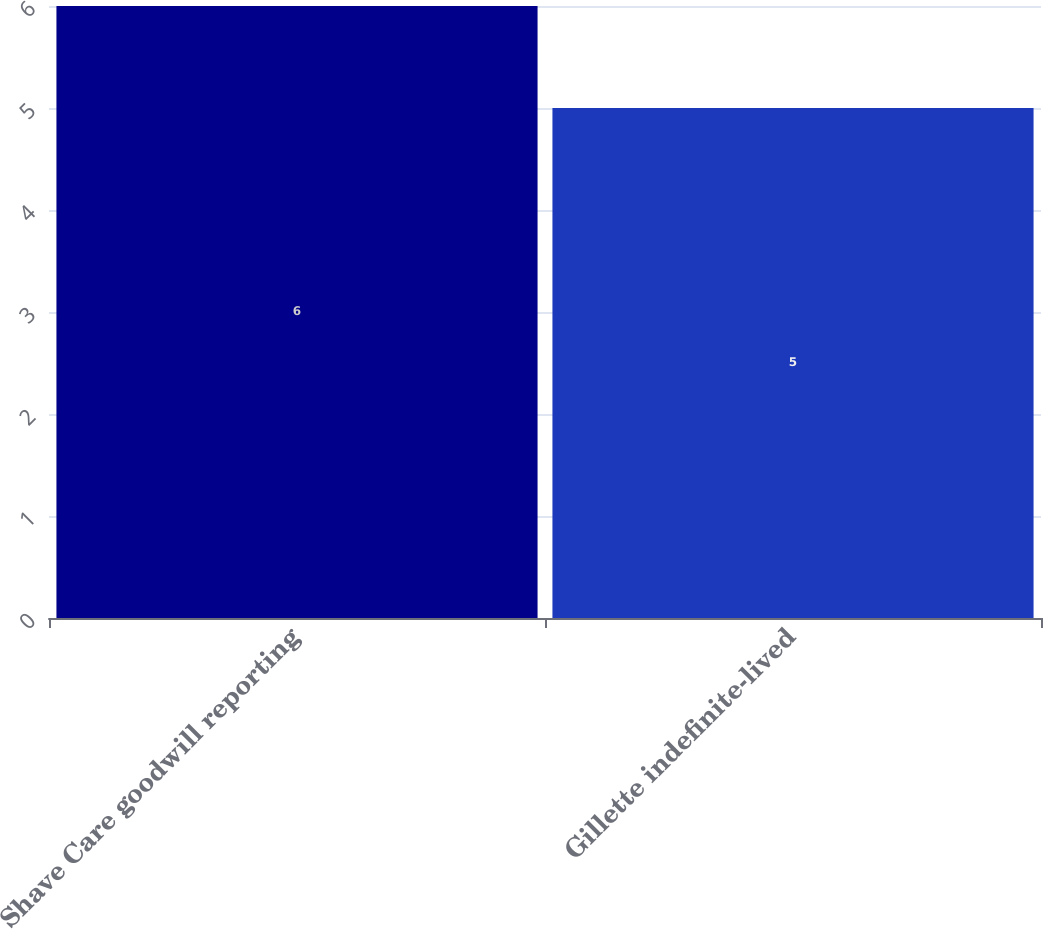Convert chart to OTSL. <chart><loc_0><loc_0><loc_500><loc_500><bar_chart><fcel>Shave Care goodwill reporting<fcel>Gillette indefinite-lived<nl><fcel>6<fcel>5<nl></chart> 